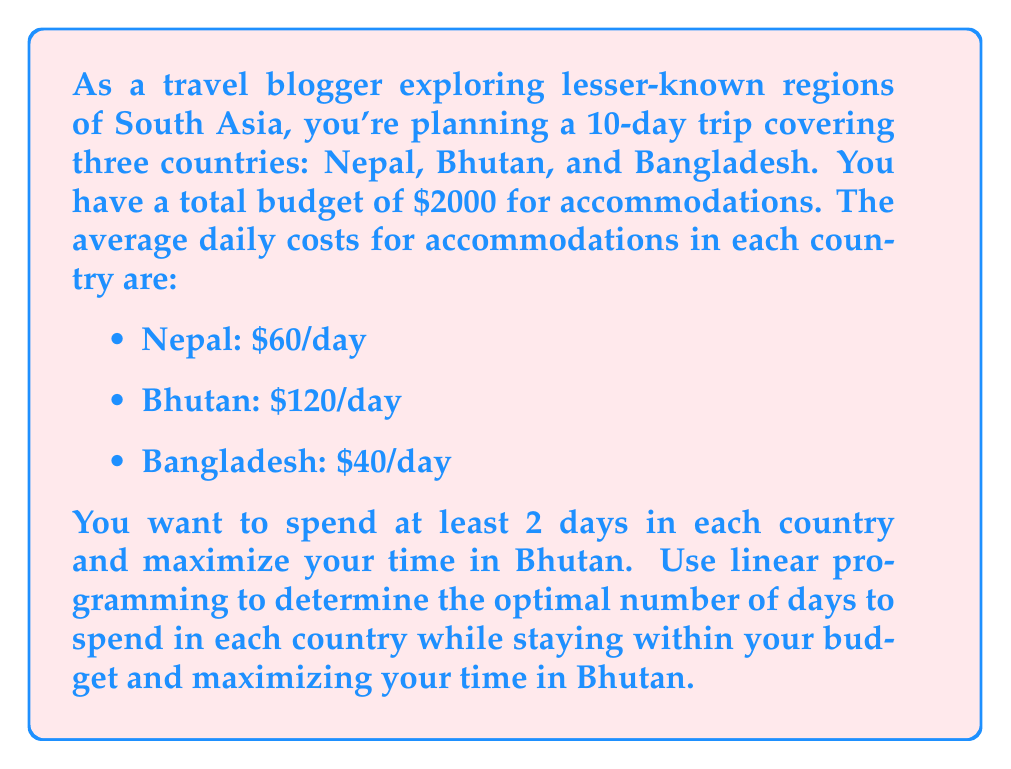Show me your answer to this math problem. To solve this problem using linear programming, we need to set up our objective function and constraints.

Let's define our variables:
$x$ = number of days in Nepal
$y$ = number of days in Bhutan
$z$ = number of days in Bangladesh

Objective function:
We want to maximize time in Bhutan, so our objective function is:
$$\text{Maximize } y$$

Constraints:
1. Total days constraint: $x + y + z = 10$
2. Budget constraint: $60x + 120y + 40z \leq 2000$
3. Minimum stay constraints: $x \geq 2$, $y \geq 2$, $z \geq 2$
4. Non-negativity constraints: $x, y, z \geq 0$

To solve this, we can use the simplex method or a graphical approach. Given the simplicity of the problem, we'll use a logical approach:

1. We know we must spend at least 2 days in each country, so let's start with that:
   $x = 2$, $y = 2$, $z = 2$
   This uses 6 days and costs: $60(2) + 120(2) + 40(2) = 440$

2. We have 4 days and $1560 left to allocate.

3. Since we want to maximize time in Bhutan, let's see how many more days we can spend there:
   $1560 / 120 = 13$ days, but we only have 4 days left.

4. So, we can allocate all 4 remaining days to Bhutan.

Final allocation:
Nepal (x): 2 days
Bhutan (y): 6 days
Bangladesh (z): 2 days

Let's verify the constraints:
- Total days: 2 + 6 + 2 = 10 ✓
- Budget: $60(2) + 120(6) + 40(2) = 880 \leq 2000$ ✓
- Minimum stay: All countries have at least 2 days ✓
Answer: The optimal allocation is:
Nepal: 2 days
Bhutan: 6 days
Bangladesh: 2 days 